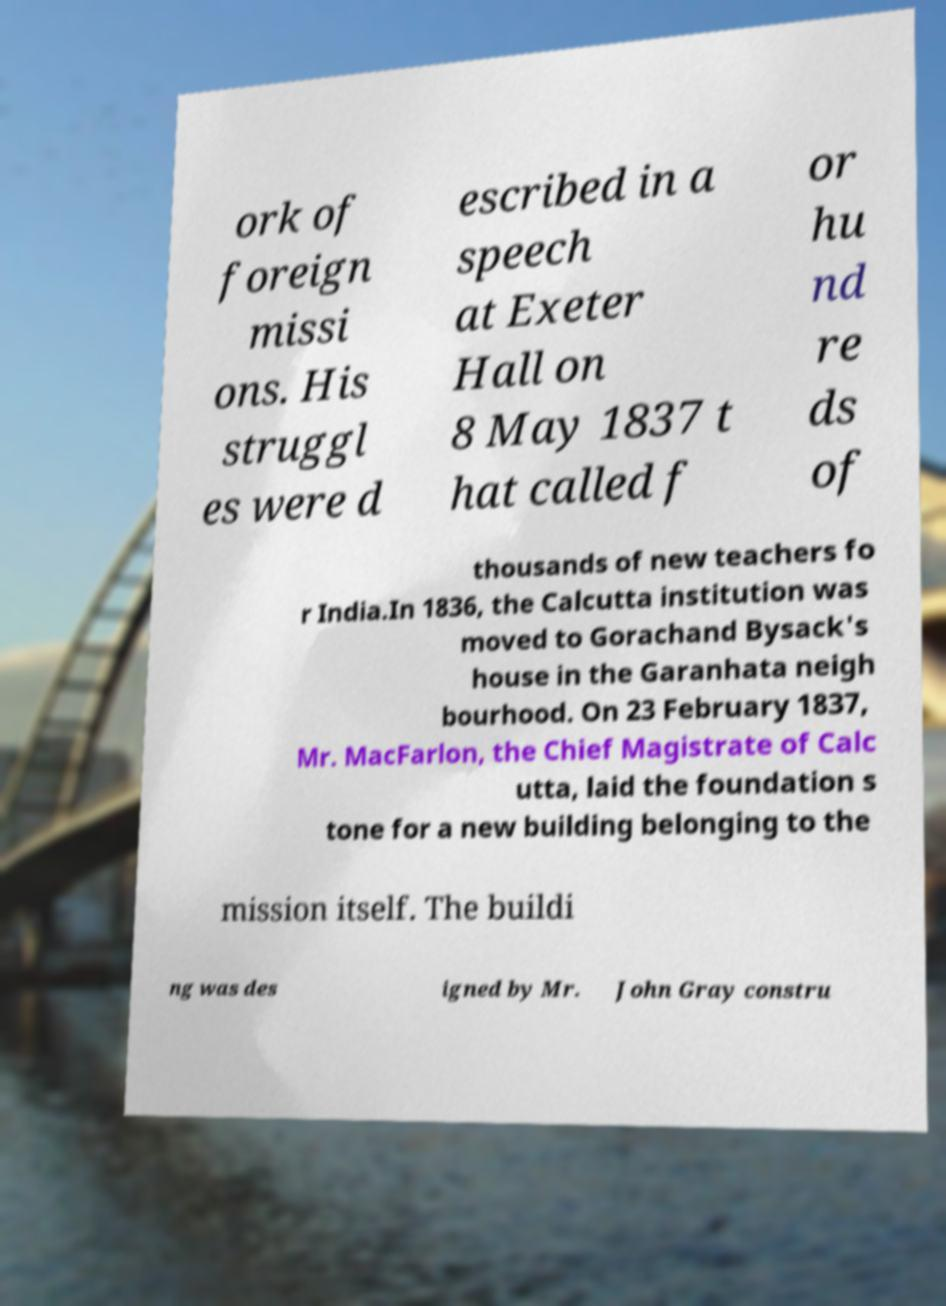Please identify and transcribe the text found in this image. ork of foreign missi ons. His struggl es were d escribed in a speech at Exeter Hall on 8 May 1837 t hat called f or hu nd re ds of thousands of new teachers fo r India.In 1836, the Calcutta institution was moved to Gorachand Bysack's house in the Garanhata neigh bourhood. On 23 February 1837, Mr. MacFarlon, the Chief Magistrate of Calc utta, laid the foundation s tone for a new building belonging to the mission itself. The buildi ng was des igned by Mr. John Gray constru 